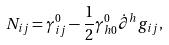Convert formula to latex. <formula><loc_0><loc_0><loc_500><loc_500>N _ { i j } = \gamma _ { i j } ^ { 0 } - \frac { 1 } { 2 } \gamma _ { h 0 } ^ { 0 } \dot { \partial } ^ { h } g _ { i j } ,</formula> 